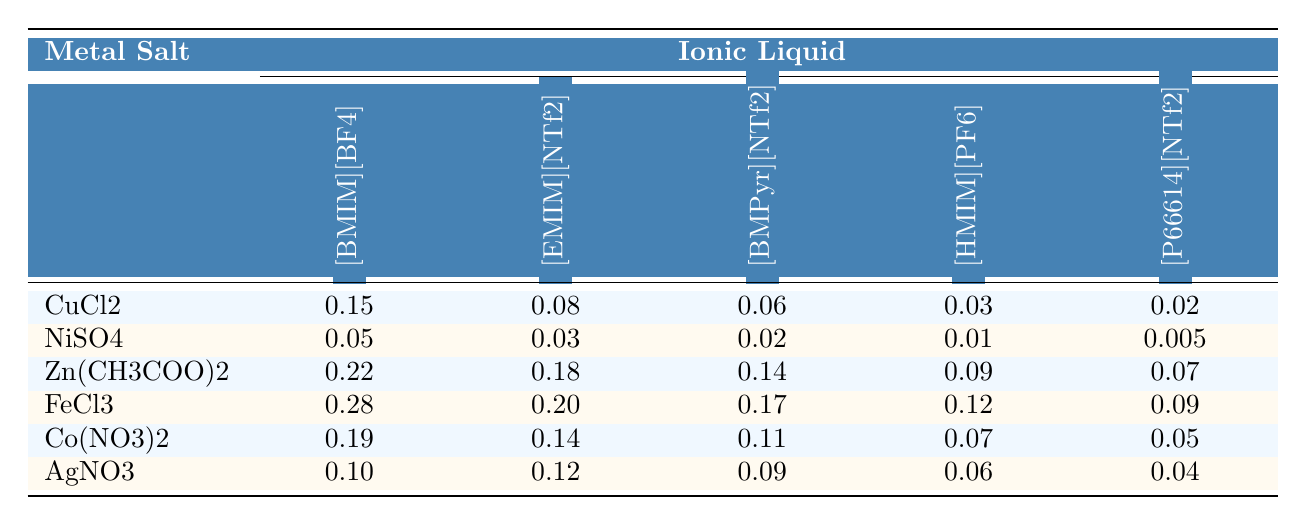What is the solubility of Zinc(II) acetate in [BMIM][BF4]? From the table, the solubility of Zinc(II) acetate (Zn(CH3COO)2) in [BMIM][BF4] is directly indicated as 0.22.
Answer: 0.22 Which ionic liquid has the highest solubility for Iron(III) chloride? Looking at the solubility values for Iron(III) chloride (FeCl3) across all ionic liquids, [BMIM][BF4] shows the highest solubility at 0.28.
Answer: [BMIM][BF4] Is the solubility of Cobalt(II) nitrate in [P66614][NTf2] greater than 0.05? The table shows that the solubility of Cobalt(II) nitrate (Co(NO3)2) in [P66614][NTf2] is 0.05, which is not greater than 0.05.
Answer: No What is the difference in solubility of Silver(I) nitrate between [EMIM][NTf2] and [BMIM][BF4]? The solubility of Silver(I) nitrate (AgNO3) in [EMIM][NTf2] is 0.12, and in [BMIM][BF4] it is 0.10. The difference is calculated as 0.12 - 0.10 = 0.02.
Answer: 0.02 Calculate the average solubility of Copper(II) chloride across all ionic liquids. The solubility of Copper(II) chloride (CuCl2) in the ionic liquids is 0.15, 0.08, 0.06, 0.03, and 0.02. The total is 0.15 + 0.08 + 0.06 + 0.03 + 0.02 = 0.34, and there are 5 data points, giving an average of 0.34 / 5 = 0.068.
Answer: 0.068 Which metal salt has the lowest overall solubility across all ionic liquids? Analyzing the solubility values for each metal salt, Nickel(II) sulfate (NiSO4) has the lowest maximum solubility value of 0.05 in [BMIM][BF4].
Answer: Nickel(II) sulfate (NiSO4) If we sum the solubility of Iron(III) chloride in all ionic liquids, what do we get? The solubility values for Iron(III) chloride (FeCl3) are 0.28, 0.20, 0.17, 0.12, and 0.09. Summing these values gives 0.28 + 0.20 + 0.17 + 0.12 + 0.09 = 0.96.
Answer: 0.96 Is the solubility of Zinc(II) acetate higher than that of Copper(II) chloride in [HMIM][PF6]? The solubility of Zinc(II) acetate (Zn(CH3COO)2) in [HMIM][PF6] is 0.09, while Copper(II) chloride (CuCl2) has a solubility of 0.03, thus, Zinc(II) acetate is higher.
Answer: Yes What is the maximum solubility of any metal salt in [EMIM][NTf2]? Among the solubility values in [EMIM][NTf2], Iron(III) chloride (FeCl3) with a solubility of 0.20 has the highest value.
Answer: 0.20 Which ionic liquid shows the least solubility overall for all metal salts? To find this, we look for the lowest solubility value across all salts in each ionic liquid. [P66614][NTf2] has the lowest solubility value of 0.005 for Nickel(II) sulfate (NiSO4), making it the least overall.
Answer: [P66614][NTf2] 